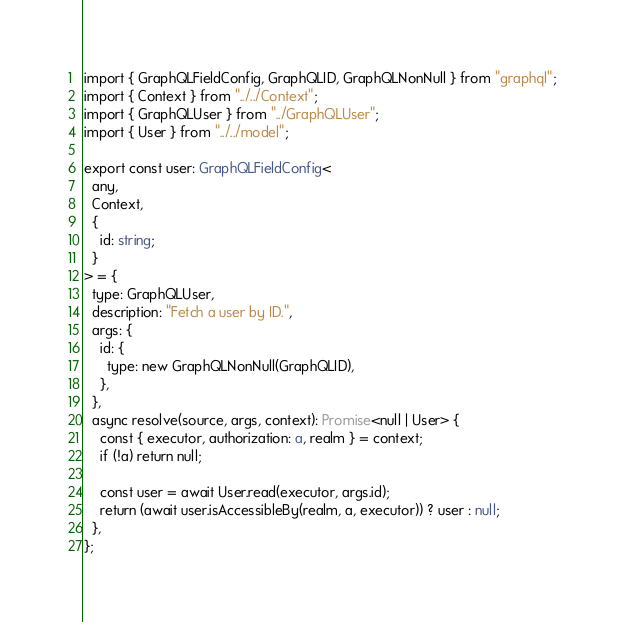<code> <loc_0><loc_0><loc_500><loc_500><_TypeScript_>import { GraphQLFieldConfig, GraphQLID, GraphQLNonNull } from "graphql";
import { Context } from "../../Context";
import { GraphQLUser } from "../GraphQLUser";
import { User } from "../../model";

export const user: GraphQLFieldConfig<
  any,
  Context,
  {
    id: string;
  }
> = {
  type: GraphQLUser,
  description: "Fetch a user by ID.",
  args: {
    id: {
      type: new GraphQLNonNull(GraphQLID),
    },
  },
  async resolve(source, args, context): Promise<null | User> {
    const { executor, authorization: a, realm } = context;
    if (!a) return null;

    const user = await User.read(executor, args.id);
    return (await user.isAccessibleBy(realm, a, executor)) ? user : null;
  },
};
</code> 